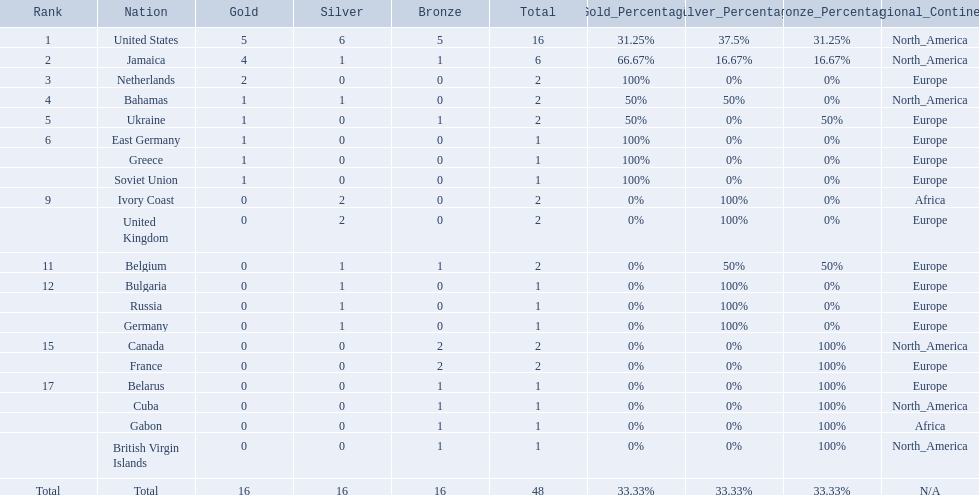Which countries competed in the 60 meters competition? United States, Jamaica, Netherlands, Bahamas, Ukraine, East Germany, Greece, Soviet Union, Ivory Coast, United Kingdom, Belgium, Bulgaria, Russia, Germany, Canada, France, Belarus, Cuba, Gabon, British Virgin Islands. And how many gold medals did they win? 5, 4, 2, 1, 1, 1, 1, 1, 0, 0, 0, 0, 0, 0, 0, 0, 0, 0, 0, 0. Of those countries, which won the second highest number gold medals? Jamaica. 